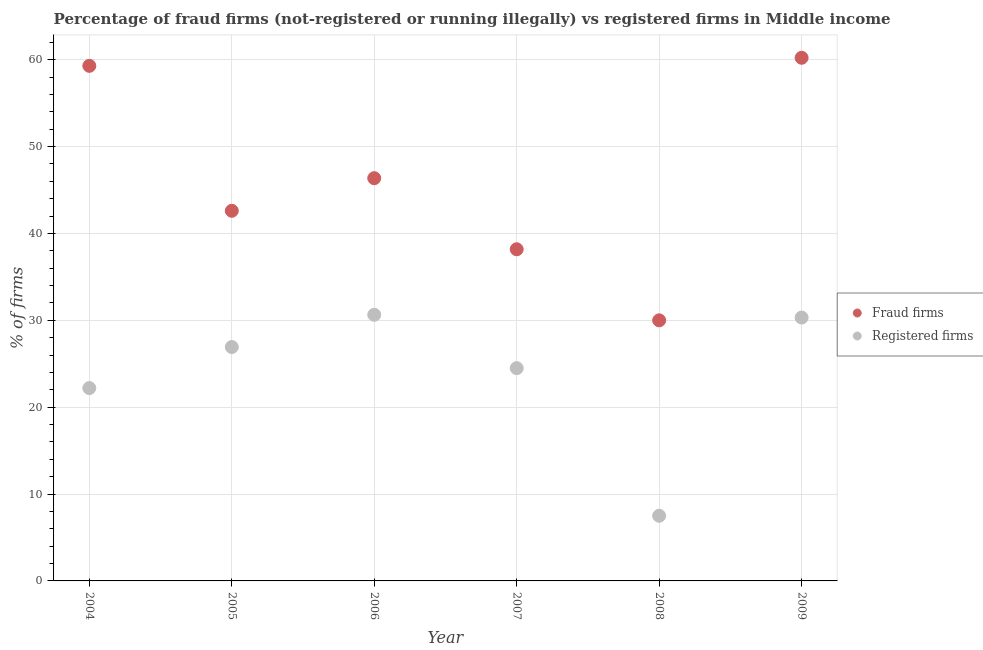How many different coloured dotlines are there?
Your response must be concise. 2. Is the number of dotlines equal to the number of legend labels?
Offer a very short reply. Yes. What is the percentage of fraud firms in 2007?
Make the answer very short. 38.18. Across all years, what is the maximum percentage of registered firms?
Offer a terse response. 30.64. In which year was the percentage of registered firms minimum?
Make the answer very short. 2008. What is the total percentage of registered firms in the graph?
Your answer should be very brief. 142.08. What is the difference between the percentage of registered firms in 2005 and that in 2007?
Your answer should be very brief. 2.43. What is the difference between the percentage of fraud firms in 2005 and the percentage of registered firms in 2009?
Your response must be concise. 12.29. What is the average percentage of registered firms per year?
Provide a succinct answer. 23.68. In the year 2005, what is the difference between the percentage of registered firms and percentage of fraud firms?
Provide a short and direct response. -15.68. In how many years, is the percentage of registered firms greater than 10 %?
Offer a terse response. 5. What is the ratio of the percentage of fraud firms in 2006 to that in 2009?
Provide a short and direct response. 0.77. Is the percentage of registered firms in 2005 less than that in 2008?
Your answer should be very brief. No. What is the difference between the highest and the second highest percentage of registered firms?
Your answer should be compact. 0.32. What is the difference between the highest and the lowest percentage of registered firms?
Offer a terse response. 23.14. In how many years, is the percentage of fraud firms greater than the average percentage of fraud firms taken over all years?
Give a very brief answer. 3. Is the sum of the percentage of registered firms in 2005 and 2008 greater than the maximum percentage of fraud firms across all years?
Ensure brevity in your answer.  No. Is the percentage of fraud firms strictly greater than the percentage of registered firms over the years?
Offer a very short reply. Yes. What is the difference between two consecutive major ticks on the Y-axis?
Offer a very short reply. 10. Does the graph contain any zero values?
Provide a short and direct response. No. Does the graph contain grids?
Keep it short and to the point. Yes. Where does the legend appear in the graph?
Ensure brevity in your answer.  Center right. How are the legend labels stacked?
Your response must be concise. Vertical. What is the title of the graph?
Your response must be concise. Percentage of fraud firms (not-registered or running illegally) vs registered firms in Middle income. What is the label or title of the X-axis?
Your answer should be compact. Year. What is the label or title of the Y-axis?
Your response must be concise. % of firms. What is the % of firms of Fraud firms in 2004?
Provide a succinct answer. 59.3. What is the % of firms of Fraud firms in 2005?
Your answer should be very brief. 42.61. What is the % of firms of Registered firms in 2005?
Your answer should be compact. 26.93. What is the % of firms of Fraud firms in 2006?
Offer a terse response. 46.36. What is the % of firms of Registered firms in 2006?
Ensure brevity in your answer.  30.64. What is the % of firms in Fraud firms in 2007?
Provide a succinct answer. 38.18. What is the % of firms of Registered firms in 2007?
Provide a succinct answer. 24.49. What is the % of firms in Fraud firms in 2009?
Give a very brief answer. 60.23. What is the % of firms in Registered firms in 2009?
Provide a succinct answer. 30.32. Across all years, what is the maximum % of firms of Fraud firms?
Offer a terse response. 60.23. Across all years, what is the maximum % of firms in Registered firms?
Make the answer very short. 30.64. Across all years, what is the minimum % of firms of Registered firms?
Your answer should be compact. 7.5. What is the total % of firms in Fraud firms in the graph?
Offer a very short reply. 276.68. What is the total % of firms of Registered firms in the graph?
Offer a very short reply. 142.08. What is the difference between the % of firms in Fraud firms in 2004 and that in 2005?
Offer a very short reply. 16.69. What is the difference between the % of firms of Registered firms in 2004 and that in 2005?
Ensure brevity in your answer.  -4.73. What is the difference between the % of firms of Fraud firms in 2004 and that in 2006?
Your answer should be very brief. 12.93. What is the difference between the % of firms of Registered firms in 2004 and that in 2006?
Your answer should be very brief. -8.44. What is the difference between the % of firms in Fraud firms in 2004 and that in 2007?
Offer a very short reply. 21.12. What is the difference between the % of firms of Registered firms in 2004 and that in 2007?
Provide a succinct answer. -2.29. What is the difference between the % of firms in Fraud firms in 2004 and that in 2008?
Make the answer very short. 29.3. What is the difference between the % of firms in Registered firms in 2004 and that in 2008?
Keep it short and to the point. 14.7. What is the difference between the % of firms in Fraud firms in 2004 and that in 2009?
Give a very brief answer. -0.93. What is the difference between the % of firms of Registered firms in 2004 and that in 2009?
Provide a short and direct response. -8.12. What is the difference between the % of firms of Fraud firms in 2005 and that in 2006?
Give a very brief answer. -3.75. What is the difference between the % of firms of Registered firms in 2005 and that in 2006?
Offer a very short reply. -3.71. What is the difference between the % of firms in Fraud firms in 2005 and that in 2007?
Provide a succinct answer. 4.43. What is the difference between the % of firms of Registered firms in 2005 and that in 2007?
Make the answer very short. 2.43. What is the difference between the % of firms in Fraud firms in 2005 and that in 2008?
Your answer should be very brief. 12.61. What is the difference between the % of firms of Registered firms in 2005 and that in 2008?
Give a very brief answer. 19.43. What is the difference between the % of firms in Fraud firms in 2005 and that in 2009?
Your answer should be compact. -17.62. What is the difference between the % of firms of Registered firms in 2005 and that in 2009?
Provide a short and direct response. -3.39. What is the difference between the % of firms of Fraud firms in 2006 and that in 2007?
Provide a succinct answer. 8.18. What is the difference between the % of firms in Registered firms in 2006 and that in 2007?
Keep it short and to the point. 6.15. What is the difference between the % of firms of Fraud firms in 2006 and that in 2008?
Ensure brevity in your answer.  16.36. What is the difference between the % of firms in Registered firms in 2006 and that in 2008?
Provide a short and direct response. 23.14. What is the difference between the % of firms in Fraud firms in 2006 and that in 2009?
Your response must be concise. -13.86. What is the difference between the % of firms in Registered firms in 2006 and that in 2009?
Make the answer very short. 0.32. What is the difference between the % of firms in Fraud firms in 2007 and that in 2008?
Your answer should be compact. 8.18. What is the difference between the % of firms of Registered firms in 2007 and that in 2008?
Ensure brevity in your answer.  16.99. What is the difference between the % of firms in Fraud firms in 2007 and that in 2009?
Your answer should be compact. -22.05. What is the difference between the % of firms of Registered firms in 2007 and that in 2009?
Your response must be concise. -5.83. What is the difference between the % of firms of Fraud firms in 2008 and that in 2009?
Your answer should be very brief. -30.23. What is the difference between the % of firms of Registered firms in 2008 and that in 2009?
Provide a succinct answer. -22.82. What is the difference between the % of firms of Fraud firms in 2004 and the % of firms of Registered firms in 2005?
Provide a short and direct response. 32.37. What is the difference between the % of firms of Fraud firms in 2004 and the % of firms of Registered firms in 2006?
Offer a very short reply. 28.66. What is the difference between the % of firms of Fraud firms in 2004 and the % of firms of Registered firms in 2007?
Your answer should be compact. 34.8. What is the difference between the % of firms of Fraud firms in 2004 and the % of firms of Registered firms in 2008?
Ensure brevity in your answer.  51.8. What is the difference between the % of firms of Fraud firms in 2004 and the % of firms of Registered firms in 2009?
Make the answer very short. 28.98. What is the difference between the % of firms of Fraud firms in 2005 and the % of firms of Registered firms in 2006?
Your answer should be compact. 11.97. What is the difference between the % of firms of Fraud firms in 2005 and the % of firms of Registered firms in 2007?
Offer a very short reply. 18.12. What is the difference between the % of firms in Fraud firms in 2005 and the % of firms in Registered firms in 2008?
Make the answer very short. 35.11. What is the difference between the % of firms of Fraud firms in 2005 and the % of firms of Registered firms in 2009?
Ensure brevity in your answer.  12.29. What is the difference between the % of firms in Fraud firms in 2006 and the % of firms in Registered firms in 2007?
Your response must be concise. 21.87. What is the difference between the % of firms of Fraud firms in 2006 and the % of firms of Registered firms in 2008?
Provide a succinct answer. 38.86. What is the difference between the % of firms of Fraud firms in 2006 and the % of firms of Registered firms in 2009?
Make the answer very short. 16.04. What is the difference between the % of firms in Fraud firms in 2007 and the % of firms in Registered firms in 2008?
Your answer should be compact. 30.68. What is the difference between the % of firms of Fraud firms in 2007 and the % of firms of Registered firms in 2009?
Your answer should be very brief. 7.86. What is the difference between the % of firms in Fraud firms in 2008 and the % of firms in Registered firms in 2009?
Give a very brief answer. -0.32. What is the average % of firms in Fraud firms per year?
Provide a short and direct response. 46.11. What is the average % of firms in Registered firms per year?
Offer a very short reply. 23.68. In the year 2004, what is the difference between the % of firms of Fraud firms and % of firms of Registered firms?
Your response must be concise. 37.1. In the year 2005, what is the difference between the % of firms of Fraud firms and % of firms of Registered firms?
Your answer should be compact. 15.68. In the year 2006, what is the difference between the % of firms in Fraud firms and % of firms in Registered firms?
Give a very brief answer. 15.72. In the year 2007, what is the difference between the % of firms of Fraud firms and % of firms of Registered firms?
Keep it short and to the point. 13.69. In the year 2009, what is the difference between the % of firms in Fraud firms and % of firms in Registered firms?
Provide a short and direct response. 29.91. What is the ratio of the % of firms in Fraud firms in 2004 to that in 2005?
Make the answer very short. 1.39. What is the ratio of the % of firms in Registered firms in 2004 to that in 2005?
Your response must be concise. 0.82. What is the ratio of the % of firms in Fraud firms in 2004 to that in 2006?
Make the answer very short. 1.28. What is the ratio of the % of firms in Registered firms in 2004 to that in 2006?
Make the answer very short. 0.72. What is the ratio of the % of firms of Fraud firms in 2004 to that in 2007?
Give a very brief answer. 1.55. What is the ratio of the % of firms of Registered firms in 2004 to that in 2007?
Your response must be concise. 0.91. What is the ratio of the % of firms of Fraud firms in 2004 to that in 2008?
Make the answer very short. 1.98. What is the ratio of the % of firms in Registered firms in 2004 to that in 2008?
Ensure brevity in your answer.  2.96. What is the ratio of the % of firms of Fraud firms in 2004 to that in 2009?
Offer a terse response. 0.98. What is the ratio of the % of firms of Registered firms in 2004 to that in 2009?
Your answer should be compact. 0.73. What is the ratio of the % of firms of Fraud firms in 2005 to that in 2006?
Provide a short and direct response. 0.92. What is the ratio of the % of firms in Registered firms in 2005 to that in 2006?
Ensure brevity in your answer.  0.88. What is the ratio of the % of firms in Fraud firms in 2005 to that in 2007?
Give a very brief answer. 1.12. What is the ratio of the % of firms of Registered firms in 2005 to that in 2007?
Give a very brief answer. 1.1. What is the ratio of the % of firms of Fraud firms in 2005 to that in 2008?
Provide a short and direct response. 1.42. What is the ratio of the % of firms of Registered firms in 2005 to that in 2008?
Ensure brevity in your answer.  3.59. What is the ratio of the % of firms in Fraud firms in 2005 to that in 2009?
Provide a succinct answer. 0.71. What is the ratio of the % of firms of Registered firms in 2005 to that in 2009?
Offer a very short reply. 0.89. What is the ratio of the % of firms of Fraud firms in 2006 to that in 2007?
Your answer should be compact. 1.21. What is the ratio of the % of firms of Registered firms in 2006 to that in 2007?
Your answer should be compact. 1.25. What is the ratio of the % of firms in Fraud firms in 2006 to that in 2008?
Your response must be concise. 1.55. What is the ratio of the % of firms of Registered firms in 2006 to that in 2008?
Ensure brevity in your answer.  4.09. What is the ratio of the % of firms in Fraud firms in 2006 to that in 2009?
Keep it short and to the point. 0.77. What is the ratio of the % of firms in Registered firms in 2006 to that in 2009?
Keep it short and to the point. 1.01. What is the ratio of the % of firms of Fraud firms in 2007 to that in 2008?
Keep it short and to the point. 1.27. What is the ratio of the % of firms in Registered firms in 2007 to that in 2008?
Your answer should be compact. 3.27. What is the ratio of the % of firms of Fraud firms in 2007 to that in 2009?
Offer a very short reply. 0.63. What is the ratio of the % of firms of Registered firms in 2007 to that in 2009?
Ensure brevity in your answer.  0.81. What is the ratio of the % of firms of Fraud firms in 2008 to that in 2009?
Your answer should be compact. 0.5. What is the ratio of the % of firms of Registered firms in 2008 to that in 2009?
Your response must be concise. 0.25. What is the difference between the highest and the second highest % of firms in Fraud firms?
Provide a succinct answer. 0.93. What is the difference between the highest and the second highest % of firms in Registered firms?
Your response must be concise. 0.32. What is the difference between the highest and the lowest % of firms of Fraud firms?
Make the answer very short. 30.23. What is the difference between the highest and the lowest % of firms in Registered firms?
Offer a very short reply. 23.14. 